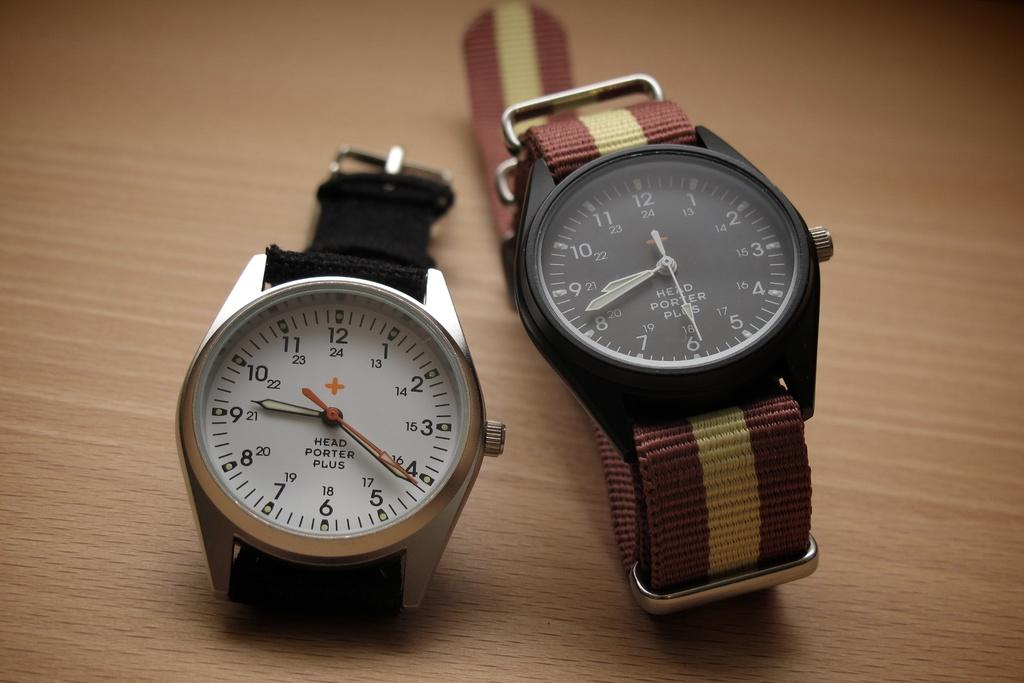<image>
Offer a succinct explanation of the picture presented. Two watches next to one another with one that says "Head Porter Plus". 